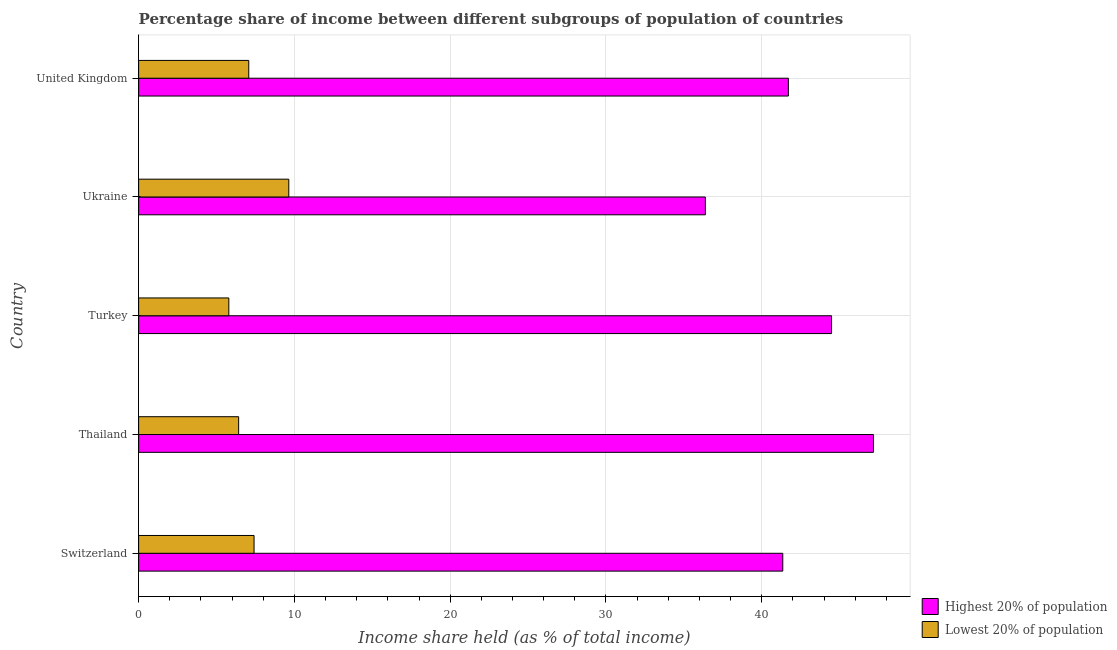How many different coloured bars are there?
Offer a terse response. 2. How many groups of bars are there?
Make the answer very short. 5. Are the number of bars per tick equal to the number of legend labels?
Offer a terse response. Yes. Are the number of bars on each tick of the Y-axis equal?
Your answer should be very brief. Yes. How many bars are there on the 4th tick from the top?
Offer a very short reply. 2. How many bars are there on the 1st tick from the bottom?
Provide a short and direct response. 2. What is the label of the 4th group of bars from the top?
Give a very brief answer. Thailand. What is the income share held by lowest 20% of the population in United Kingdom?
Keep it short and to the point. 7.07. Across all countries, what is the maximum income share held by lowest 20% of the population?
Provide a succinct answer. 9.64. Across all countries, what is the minimum income share held by highest 20% of the population?
Offer a terse response. 36.38. In which country was the income share held by highest 20% of the population maximum?
Give a very brief answer. Thailand. What is the total income share held by lowest 20% of the population in the graph?
Keep it short and to the point. 36.33. What is the difference between the income share held by lowest 20% of the population in Switzerland and that in Ukraine?
Your response must be concise. -2.23. What is the difference between the income share held by highest 20% of the population in Thailand and the income share held by lowest 20% of the population in Switzerland?
Give a very brief answer. 39.76. What is the average income share held by lowest 20% of the population per country?
Give a very brief answer. 7.27. What is the difference between the income share held by lowest 20% of the population and income share held by highest 20% of the population in Turkey?
Your response must be concise. -38.69. In how many countries, is the income share held by highest 20% of the population greater than 18 %?
Provide a short and direct response. 5. Is the difference between the income share held by lowest 20% of the population in Switzerland and United Kingdom greater than the difference between the income share held by highest 20% of the population in Switzerland and United Kingdom?
Keep it short and to the point. Yes. What is the difference between the highest and the second highest income share held by lowest 20% of the population?
Keep it short and to the point. 2.23. What is the difference between the highest and the lowest income share held by highest 20% of the population?
Your answer should be very brief. 10.79. In how many countries, is the income share held by lowest 20% of the population greater than the average income share held by lowest 20% of the population taken over all countries?
Provide a short and direct response. 2. What does the 2nd bar from the top in United Kingdom represents?
Your answer should be very brief. Highest 20% of population. What does the 2nd bar from the bottom in Turkey represents?
Offer a terse response. Lowest 20% of population. Are all the bars in the graph horizontal?
Offer a very short reply. Yes. How many countries are there in the graph?
Offer a terse response. 5. Does the graph contain any zero values?
Provide a short and direct response. No. Where does the legend appear in the graph?
Offer a very short reply. Bottom right. What is the title of the graph?
Give a very brief answer. Percentage share of income between different subgroups of population of countries. What is the label or title of the X-axis?
Ensure brevity in your answer.  Income share held (as % of total income). What is the Income share held (as % of total income) of Highest 20% of population in Switzerland?
Give a very brief answer. 41.35. What is the Income share held (as % of total income) in Lowest 20% of population in Switzerland?
Provide a succinct answer. 7.41. What is the Income share held (as % of total income) in Highest 20% of population in Thailand?
Provide a succinct answer. 47.17. What is the Income share held (as % of total income) in Lowest 20% of population in Thailand?
Ensure brevity in your answer.  6.42. What is the Income share held (as % of total income) in Highest 20% of population in Turkey?
Your answer should be very brief. 44.48. What is the Income share held (as % of total income) in Lowest 20% of population in Turkey?
Keep it short and to the point. 5.79. What is the Income share held (as % of total income) in Highest 20% of population in Ukraine?
Ensure brevity in your answer.  36.38. What is the Income share held (as % of total income) of Lowest 20% of population in Ukraine?
Give a very brief answer. 9.64. What is the Income share held (as % of total income) of Highest 20% of population in United Kingdom?
Offer a terse response. 41.71. What is the Income share held (as % of total income) of Lowest 20% of population in United Kingdom?
Keep it short and to the point. 7.07. Across all countries, what is the maximum Income share held (as % of total income) of Highest 20% of population?
Provide a succinct answer. 47.17. Across all countries, what is the maximum Income share held (as % of total income) of Lowest 20% of population?
Your answer should be very brief. 9.64. Across all countries, what is the minimum Income share held (as % of total income) in Highest 20% of population?
Your answer should be very brief. 36.38. Across all countries, what is the minimum Income share held (as % of total income) in Lowest 20% of population?
Provide a succinct answer. 5.79. What is the total Income share held (as % of total income) of Highest 20% of population in the graph?
Ensure brevity in your answer.  211.09. What is the total Income share held (as % of total income) of Lowest 20% of population in the graph?
Your answer should be compact. 36.33. What is the difference between the Income share held (as % of total income) of Highest 20% of population in Switzerland and that in Thailand?
Your answer should be compact. -5.82. What is the difference between the Income share held (as % of total income) of Lowest 20% of population in Switzerland and that in Thailand?
Your answer should be very brief. 0.99. What is the difference between the Income share held (as % of total income) in Highest 20% of population in Switzerland and that in Turkey?
Your answer should be compact. -3.13. What is the difference between the Income share held (as % of total income) of Lowest 20% of population in Switzerland and that in Turkey?
Make the answer very short. 1.62. What is the difference between the Income share held (as % of total income) of Highest 20% of population in Switzerland and that in Ukraine?
Your answer should be compact. 4.97. What is the difference between the Income share held (as % of total income) of Lowest 20% of population in Switzerland and that in Ukraine?
Your response must be concise. -2.23. What is the difference between the Income share held (as % of total income) in Highest 20% of population in Switzerland and that in United Kingdom?
Your response must be concise. -0.36. What is the difference between the Income share held (as % of total income) of Lowest 20% of population in Switzerland and that in United Kingdom?
Offer a terse response. 0.34. What is the difference between the Income share held (as % of total income) of Highest 20% of population in Thailand and that in Turkey?
Ensure brevity in your answer.  2.69. What is the difference between the Income share held (as % of total income) in Lowest 20% of population in Thailand and that in Turkey?
Provide a short and direct response. 0.63. What is the difference between the Income share held (as % of total income) of Highest 20% of population in Thailand and that in Ukraine?
Offer a very short reply. 10.79. What is the difference between the Income share held (as % of total income) in Lowest 20% of population in Thailand and that in Ukraine?
Keep it short and to the point. -3.22. What is the difference between the Income share held (as % of total income) in Highest 20% of population in Thailand and that in United Kingdom?
Your answer should be compact. 5.46. What is the difference between the Income share held (as % of total income) of Lowest 20% of population in Thailand and that in United Kingdom?
Give a very brief answer. -0.65. What is the difference between the Income share held (as % of total income) in Lowest 20% of population in Turkey and that in Ukraine?
Provide a short and direct response. -3.85. What is the difference between the Income share held (as % of total income) of Highest 20% of population in Turkey and that in United Kingdom?
Your response must be concise. 2.77. What is the difference between the Income share held (as % of total income) of Lowest 20% of population in Turkey and that in United Kingdom?
Offer a very short reply. -1.28. What is the difference between the Income share held (as % of total income) of Highest 20% of population in Ukraine and that in United Kingdom?
Provide a short and direct response. -5.33. What is the difference between the Income share held (as % of total income) in Lowest 20% of population in Ukraine and that in United Kingdom?
Provide a succinct answer. 2.57. What is the difference between the Income share held (as % of total income) in Highest 20% of population in Switzerland and the Income share held (as % of total income) in Lowest 20% of population in Thailand?
Your answer should be very brief. 34.93. What is the difference between the Income share held (as % of total income) of Highest 20% of population in Switzerland and the Income share held (as % of total income) of Lowest 20% of population in Turkey?
Give a very brief answer. 35.56. What is the difference between the Income share held (as % of total income) of Highest 20% of population in Switzerland and the Income share held (as % of total income) of Lowest 20% of population in Ukraine?
Your answer should be compact. 31.71. What is the difference between the Income share held (as % of total income) in Highest 20% of population in Switzerland and the Income share held (as % of total income) in Lowest 20% of population in United Kingdom?
Offer a very short reply. 34.28. What is the difference between the Income share held (as % of total income) of Highest 20% of population in Thailand and the Income share held (as % of total income) of Lowest 20% of population in Turkey?
Provide a succinct answer. 41.38. What is the difference between the Income share held (as % of total income) in Highest 20% of population in Thailand and the Income share held (as % of total income) in Lowest 20% of population in Ukraine?
Keep it short and to the point. 37.53. What is the difference between the Income share held (as % of total income) in Highest 20% of population in Thailand and the Income share held (as % of total income) in Lowest 20% of population in United Kingdom?
Keep it short and to the point. 40.1. What is the difference between the Income share held (as % of total income) of Highest 20% of population in Turkey and the Income share held (as % of total income) of Lowest 20% of population in Ukraine?
Offer a terse response. 34.84. What is the difference between the Income share held (as % of total income) in Highest 20% of population in Turkey and the Income share held (as % of total income) in Lowest 20% of population in United Kingdom?
Give a very brief answer. 37.41. What is the difference between the Income share held (as % of total income) in Highest 20% of population in Ukraine and the Income share held (as % of total income) in Lowest 20% of population in United Kingdom?
Make the answer very short. 29.31. What is the average Income share held (as % of total income) in Highest 20% of population per country?
Your answer should be very brief. 42.22. What is the average Income share held (as % of total income) of Lowest 20% of population per country?
Ensure brevity in your answer.  7.27. What is the difference between the Income share held (as % of total income) in Highest 20% of population and Income share held (as % of total income) in Lowest 20% of population in Switzerland?
Keep it short and to the point. 33.94. What is the difference between the Income share held (as % of total income) of Highest 20% of population and Income share held (as % of total income) of Lowest 20% of population in Thailand?
Your answer should be very brief. 40.75. What is the difference between the Income share held (as % of total income) of Highest 20% of population and Income share held (as % of total income) of Lowest 20% of population in Turkey?
Provide a short and direct response. 38.69. What is the difference between the Income share held (as % of total income) in Highest 20% of population and Income share held (as % of total income) in Lowest 20% of population in Ukraine?
Offer a terse response. 26.74. What is the difference between the Income share held (as % of total income) in Highest 20% of population and Income share held (as % of total income) in Lowest 20% of population in United Kingdom?
Ensure brevity in your answer.  34.64. What is the ratio of the Income share held (as % of total income) of Highest 20% of population in Switzerland to that in Thailand?
Provide a short and direct response. 0.88. What is the ratio of the Income share held (as % of total income) of Lowest 20% of population in Switzerland to that in Thailand?
Ensure brevity in your answer.  1.15. What is the ratio of the Income share held (as % of total income) of Highest 20% of population in Switzerland to that in Turkey?
Offer a terse response. 0.93. What is the ratio of the Income share held (as % of total income) of Lowest 20% of population in Switzerland to that in Turkey?
Give a very brief answer. 1.28. What is the ratio of the Income share held (as % of total income) of Highest 20% of population in Switzerland to that in Ukraine?
Ensure brevity in your answer.  1.14. What is the ratio of the Income share held (as % of total income) of Lowest 20% of population in Switzerland to that in Ukraine?
Make the answer very short. 0.77. What is the ratio of the Income share held (as % of total income) of Lowest 20% of population in Switzerland to that in United Kingdom?
Offer a terse response. 1.05. What is the ratio of the Income share held (as % of total income) in Highest 20% of population in Thailand to that in Turkey?
Provide a short and direct response. 1.06. What is the ratio of the Income share held (as % of total income) of Lowest 20% of population in Thailand to that in Turkey?
Your answer should be compact. 1.11. What is the ratio of the Income share held (as % of total income) of Highest 20% of population in Thailand to that in Ukraine?
Provide a short and direct response. 1.3. What is the ratio of the Income share held (as % of total income) in Lowest 20% of population in Thailand to that in Ukraine?
Your answer should be very brief. 0.67. What is the ratio of the Income share held (as % of total income) of Highest 20% of population in Thailand to that in United Kingdom?
Your answer should be very brief. 1.13. What is the ratio of the Income share held (as % of total income) in Lowest 20% of population in Thailand to that in United Kingdom?
Offer a very short reply. 0.91. What is the ratio of the Income share held (as % of total income) of Highest 20% of population in Turkey to that in Ukraine?
Provide a short and direct response. 1.22. What is the ratio of the Income share held (as % of total income) in Lowest 20% of population in Turkey to that in Ukraine?
Give a very brief answer. 0.6. What is the ratio of the Income share held (as % of total income) in Highest 20% of population in Turkey to that in United Kingdom?
Your answer should be very brief. 1.07. What is the ratio of the Income share held (as % of total income) of Lowest 20% of population in Turkey to that in United Kingdom?
Offer a terse response. 0.82. What is the ratio of the Income share held (as % of total income) of Highest 20% of population in Ukraine to that in United Kingdom?
Give a very brief answer. 0.87. What is the ratio of the Income share held (as % of total income) of Lowest 20% of population in Ukraine to that in United Kingdom?
Make the answer very short. 1.36. What is the difference between the highest and the second highest Income share held (as % of total income) of Highest 20% of population?
Your answer should be very brief. 2.69. What is the difference between the highest and the second highest Income share held (as % of total income) in Lowest 20% of population?
Give a very brief answer. 2.23. What is the difference between the highest and the lowest Income share held (as % of total income) of Highest 20% of population?
Your answer should be compact. 10.79. What is the difference between the highest and the lowest Income share held (as % of total income) of Lowest 20% of population?
Provide a succinct answer. 3.85. 